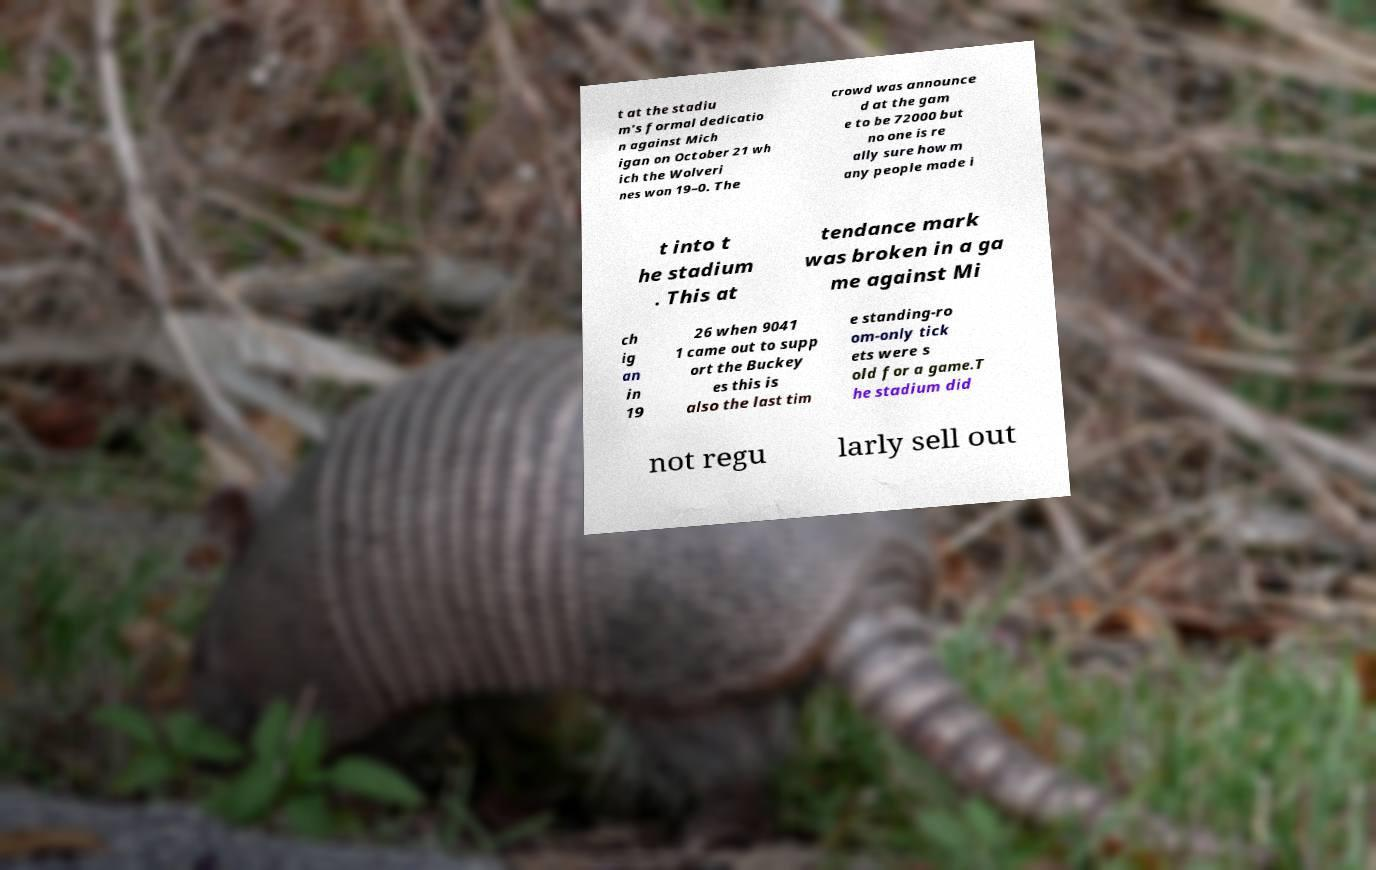What messages or text are displayed in this image? I need them in a readable, typed format. t at the stadiu m's formal dedicatio n against Mich igan on October 21 wh ich the Wolveri nes won 19–0. The crowd was announce d at the gam e to be 72000 but no one is re ally sure how m any people made i t into t he stadium . This at tendance mark was broken in a ga me against Mi ch ig an in 19 26 when 9041 1 came out to supp ort the Buckey es this is also the last tim e standing-ro om-only tick ets were s old for a game.T he stadium did not regu larly sell out 